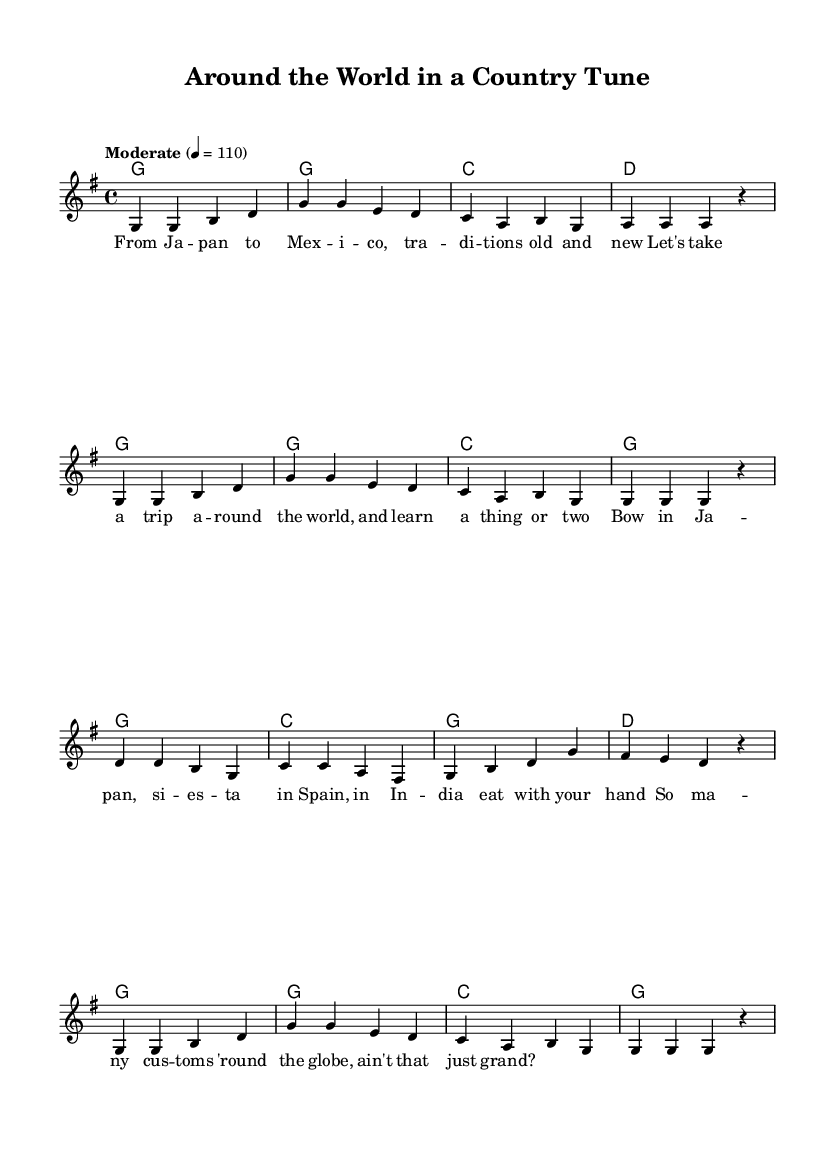What is the time signature of this music? The time signature is indicated at the beginning of the music, which shows that there are four beats per measure and the quarter note gets one beat.
Answer: 4/4 What key is this piece written in? The key signature is placed before the treble clef and indicates the piece is in G major, which has one sharp (F#).
Answer: G major What is the tempo marking of this piece? The tempo marking is indicated right after the time signature, showing that the music should be played at a moderate speed, specifically 110 beats per minute.
Answer: Moderate 4 = 110 How many measures are in the melody? By counting the number of bar lines in the melody section, we can see there are a total of 12 measures in the melody.
Answer: 12 What musical form is displayed in this piece? The structure of this piece displays a verse, where the lyrics are set to the melody, typical of many country songs that tell a story or share traditions.
Answer: Verse Which country traditions are mentioned in the lyrics? By examining the lyrics closely, we can identify that the traditions of Japan, Mexico, Spain, and India are mentioned in the song.
Answer: Japan, Mexico, Spain, India What is the first line of the lyrics? The lyrics start at the beginning of the verse, providing an introduction to the song that discusses different traditions around the world.
Answer: From Japan to Mexico, traditions old and new 